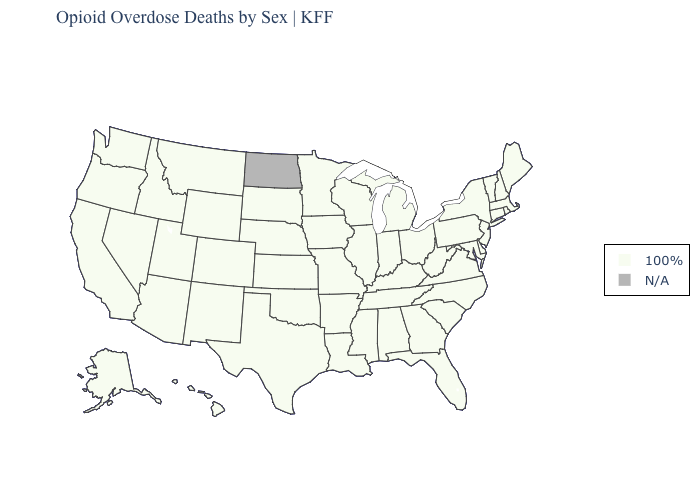Name the states that have a value in the range 100%?
Quick response, please. Alabama, Alaska, Arizona, Arkansas, California, Colorado, Connecticut, Delaware, Florida, Georgia, Hawaii, Idaho, Illinois, Indiana, Iowa, Kansas, Kentucky, Louisiana, Maine, Maryland, Massachusetts, Michigan, Minnesota, Mississippi, Missouri, Montana, Nebraska, Nevada, New Hampshire, New Jersey, New Mexico, New York, North Carolina, Ohio, Oklahoma, Oregon, Pennsylvania, Rhode Island, South Carolina, South Dakota, Tennessee, Texas, Utah, Vermont, Virginia, Washington, West Virginia, Wisconsin, Wyoming. Does the first symbol in the legend represent the smallest category?
Give a very brief answer. Yes. Is the legend a continuous bar?
Write a very short answer. No. Name the states that have a value in the range N/A?
Be succinct. North Dakota. Among the states that border Idaho , which have the highest value?
Keep it brief. Montana, Nevada, Oregon, Utah, Washington, Wyoming. What is the lowest value in the South?
Quick response, please. 100%. Which states have the lowest value in the USA?
Answer briefly. Alabama, Alaska, Arizona, Arkansas, California, Colorado, Connecticut, Delaware, Florida, Georgia, Hawaii, Idaho, Illinois, Indiana, Iowa, Kansas, Kentucky, Louisiana, Maine, Maryland, Massachusetts, Michigan, Minnesota, Mississippi, Missouri, Montana, Nebraska, Nevada, New Hampshire, New Jersey, New Mexico, New York, North Carolina, Ohio, Oklahoma, Oregon, Pennsylvania, Rhode Island, South Carolina, South Dakota, Tennessee, Texas, Utah, Vermont, Virginia, Washington, West Virginia, Wisconsin, Wyoming. How many symbols are there in the legend?
Write a very short answer. 2. Name the states that have a value in the range 100%?
Keep it brief. Alabama, Alaska, Arizona, Arkansas, California, Colorado, Connecticut, Delaware, Florida, Georgia, Hawaii, Idaho, Illinois, Indiana, Iowa, Kansas, Kentucky, Louisiana, Maine, Maryland, Massachusetts, Michigan, Minnesota, Mississippi, Missouri, Montana, Nebraska, Nevada, New Hampshire, New Jersey, New Mexico, New York, North Carolina, Ohio, Oklahoma, Oregon, Pennsylvania, Rhode Island, South Carolina, South Dakota, Tennessee, Texas, Utah, Vermont, Virginia, Washington, West Virginia, Wisconsin, Wyoming. 